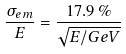Convert formula to latex. <formula><loc_0><loc_0><loc_500><loc_500>\frac { \sigma _ { e m } } { E } = \frac { 1 7 . 9 \, \% } { \sqrt { E / G e V } }</formula> 